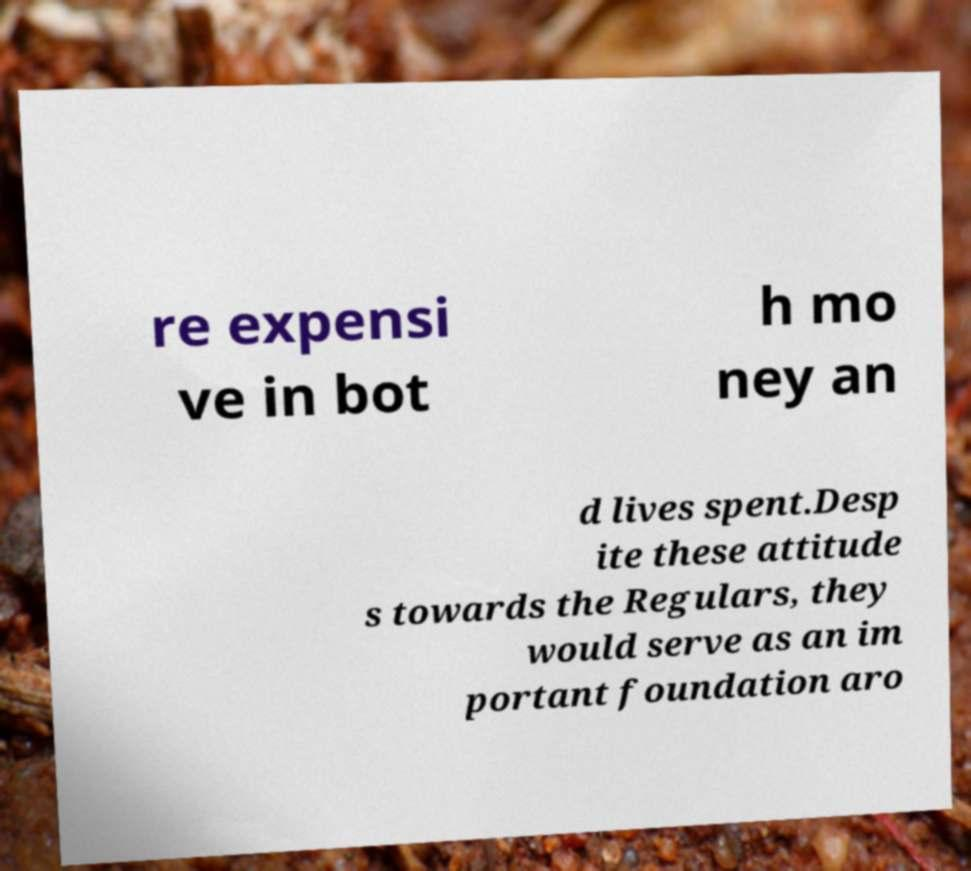Can you accurately transcribe the text from the provided image for me? re expensi ve in bot h mo ney an d lives spent.Desp ite these attitude s towards the Regulars, they would serve as an im portant foundation aro 